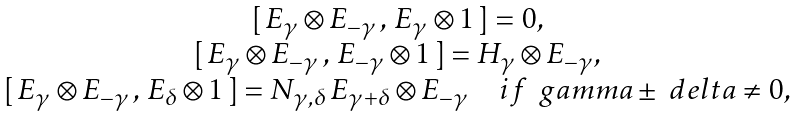<formula> <loc_0><loc_0><loc_500><loc_500>\begin{array} { c } { { [ \, E _ { \gamma } \otimes E _ { - \gamma } \, , \, E _ { \gamma } \otimes 1 \, ] = 0 , } } \\ { { [ \, E _ { \gamma } \otimes E _ { - \gamma } \, , \, E _ { - \gamma } \otimes 1 \, ] = H _ { \gamma } \otimes E _ { - \gamma } , } } \\ { { [ \, E _ { \gamma } \otimes E _ { - \gamma } \, , \, E _ { \delta } \otimes 1 \, ] = N _ { \gamma , \delta } \, E _ { \gamma + \delta } \otimes E _ { - \gamma } \quad i f \, \ g a m m a \pm \ d e l t a \neq 0 , } } \end{array}</formula> 